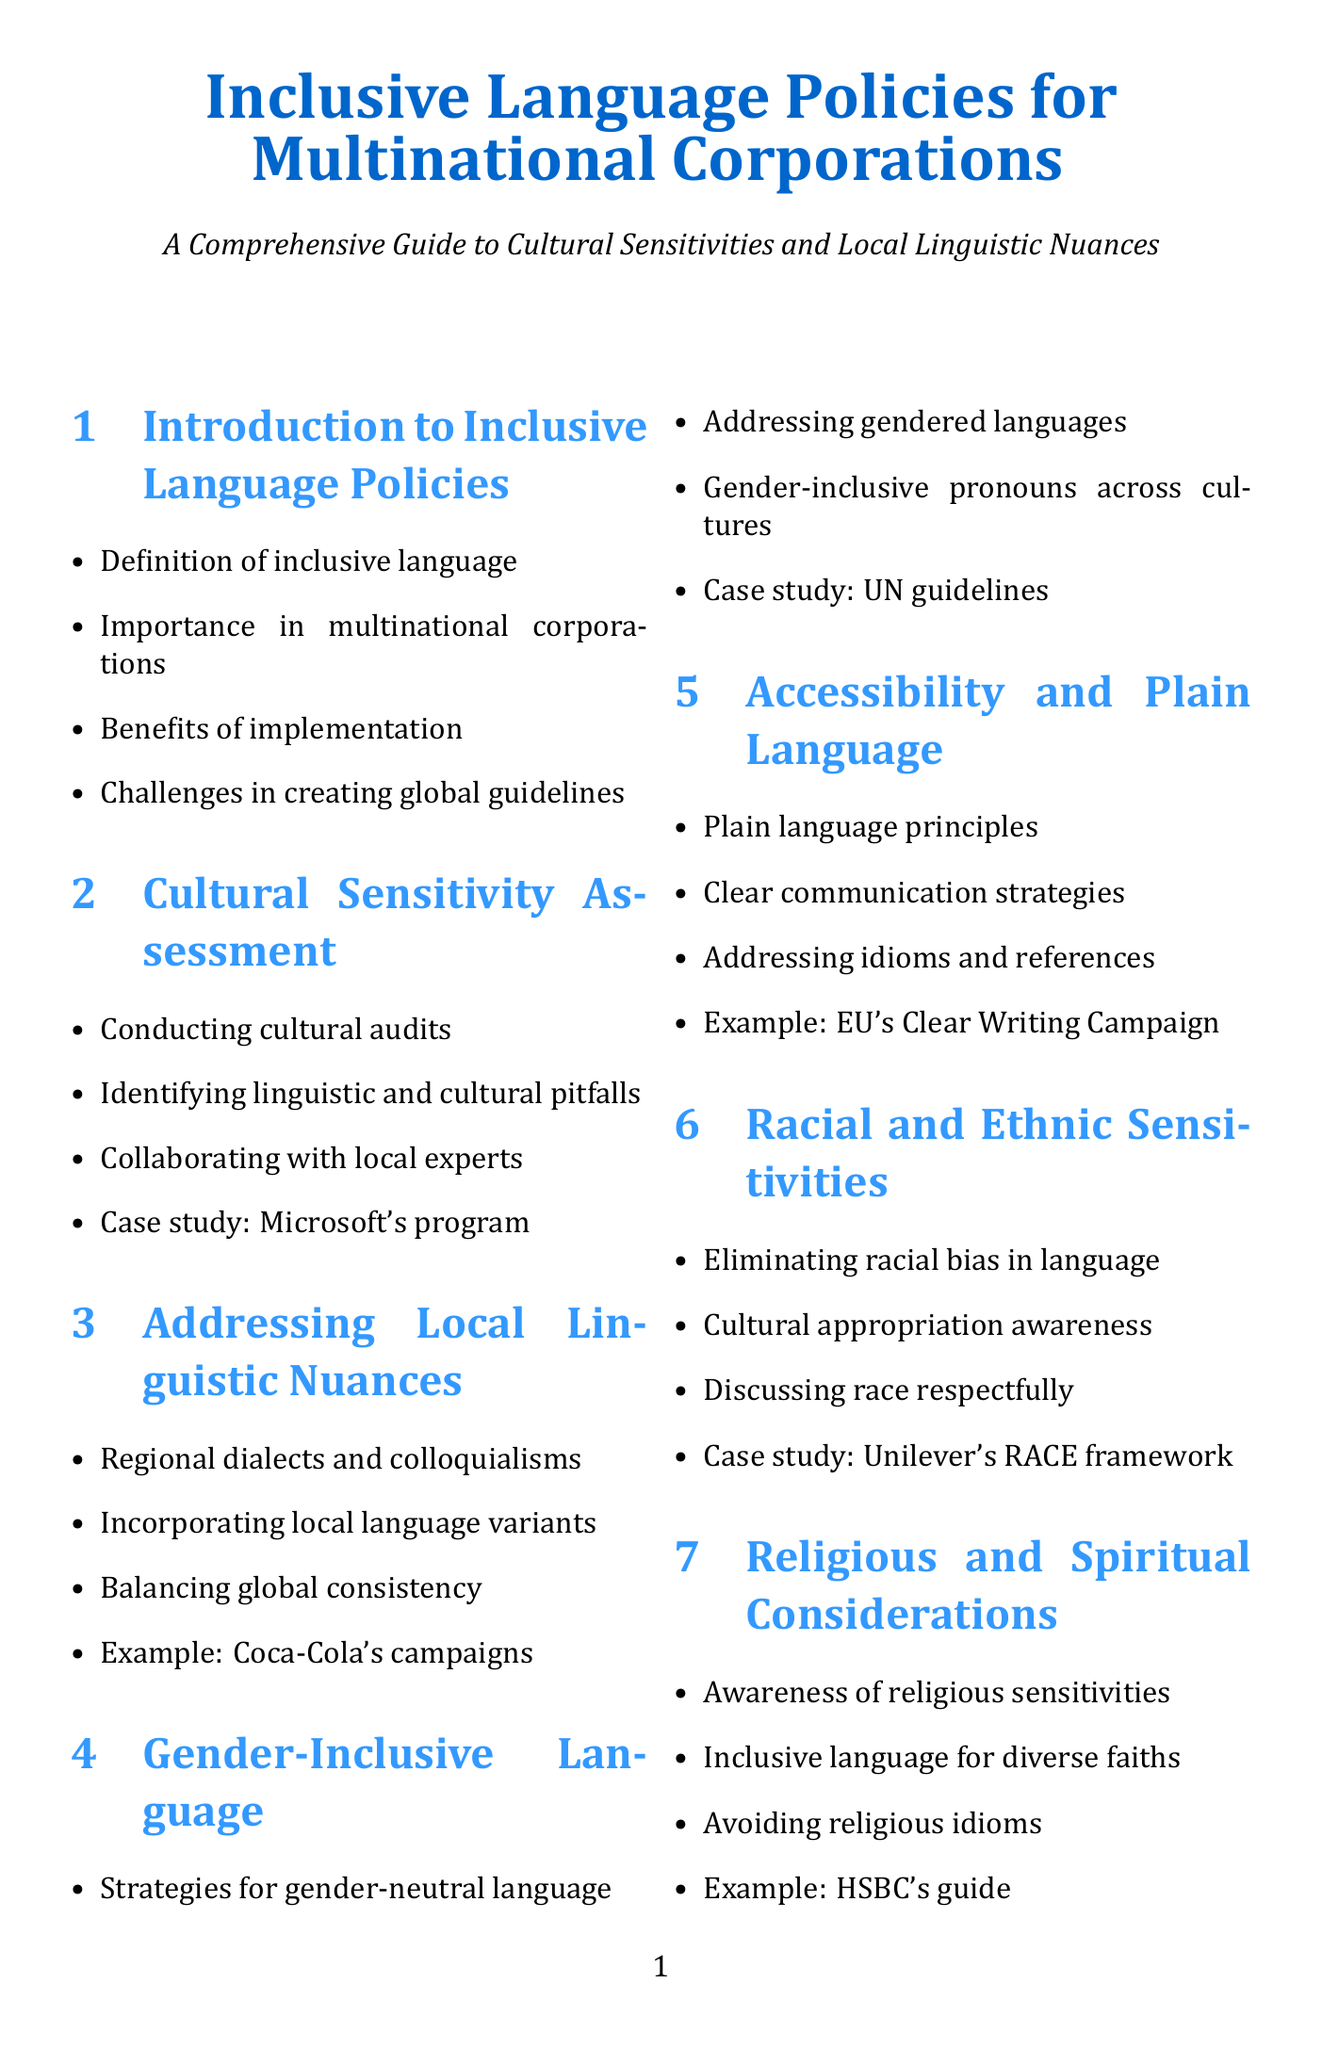What is included in the introduction to inclusive language policies? The introduction includes the definition of inclusive language, the importance of inclusive language in multinational corporations, benefits of implementing inclusive language policies, and challenges in creating global inclusive language guidelines.
Answer: Definition of inclusive language, importance, benefits, challenges What strategies does the manual suggest for gender-inclusive language? The manual suggests strategies for gender-neutral language in various languages, addressing gendered languages, use of gender-inclusive pronouns across cultures, and includes a case study on the UN's guidelines.
Answer: Strategies for gender-neutral language Which company's marketing campaigns are referenced as examples of addressing local linguistic nuances? Coca-Cola's localized marketing campaigns are mentioned in the section discussing local linguistic nuances.
Answer: Coca-Cola What is a key focus of the accessibility and plain language section? The section focuses on incorporating plain language principles for global understanding and strategies for clear communication across language barriers.
Answer: Incorporating plain language principles How many appendices are listed in the manual? The document lists three appendices, namely the glossary of inclusive terms, sample inclusive language policy template, and resources for further learning.
Answer: Three What is the purpose of the cultural sensitivity assessment section? This section aims to conduct cultural audits across global offices, identify potential linguistic and cultural pitfalls, and collaborate with local language experts and cultural consultants.
Answer: Conduct cultural audits across global offices What is the case study highlighted in the racial and ethnic sensitivities section? The case study mentioned is Unilever's RACE framework for inclusive marketing, which illustrates strategies for discussing race and ethnicity respectfully.
Answer: Unilever's RACE framework What are the legal considerations addressed in the manual? The manual covers aligning inclusive language policies with anti-discrimination laws, addressing country-specific legal requirements, and balancing free speech and inclusive language in the workplace.
Answer: Aligning with anti-discrimination laws What technologies are mentioned in the conclusion for future trends in inclusive language? The conclusion mentions emerging technologies such as AI writing assistants as part of future trends in inclusive language.
Answer: AI writing assistants 